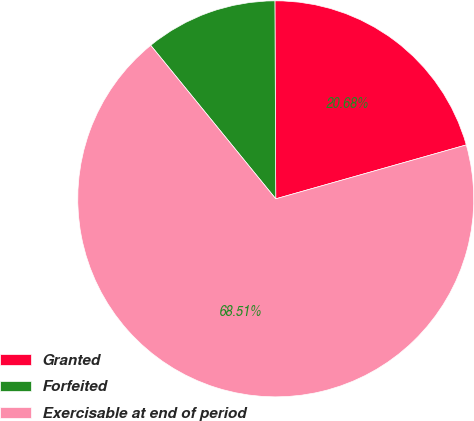Convert chart. <chart><loc_0><loc_0><loc_500><loc_500><pie_chart><fcel>Granted<fcel>Forfeited<fcel>Exercisable at end of period<nl><fcel>20.68%<fcel>10.81%<fcel>68.51%<nl></chart> 